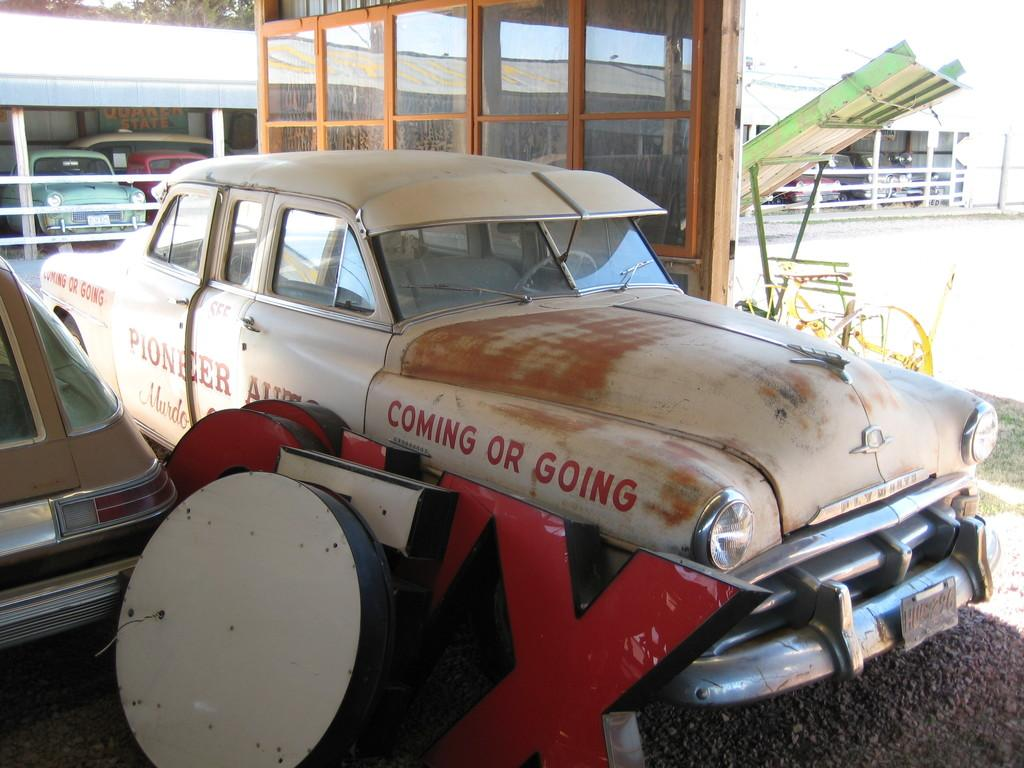<image>
Relay a brief, clear account of the picture shown. An old white car in a lot with the words "coming or going" on its side. 